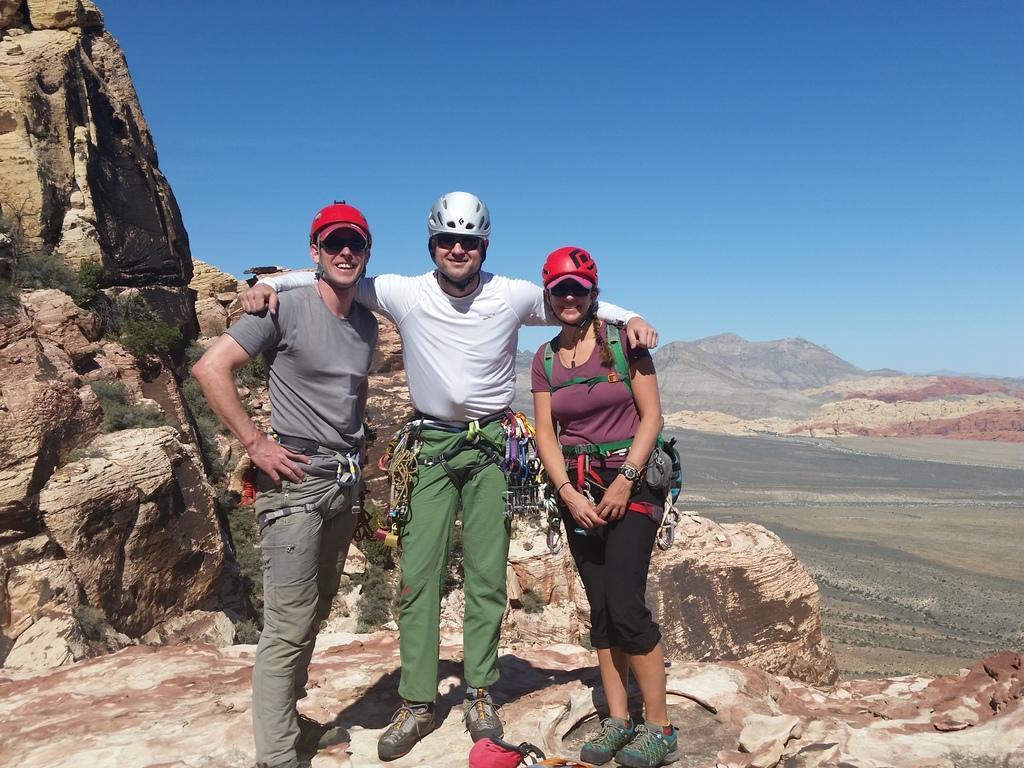How would you summarize this image in a sentence or two? This picture is clicked outside. In the center we can see the group of persons wearing t-shirts and standing on the rocks. In the background we can see the rocks and the sky and a water body. 